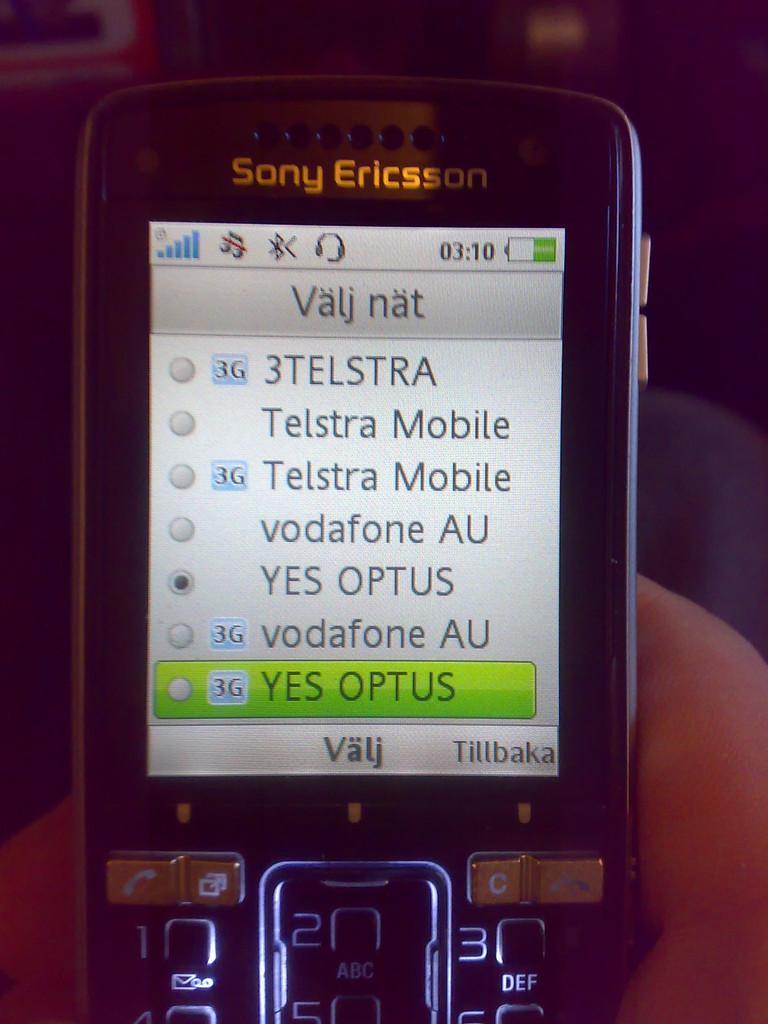<image>
Offer a succinct explanation of the picture presented. A person is holding a phone that says Sony Ericsson. 